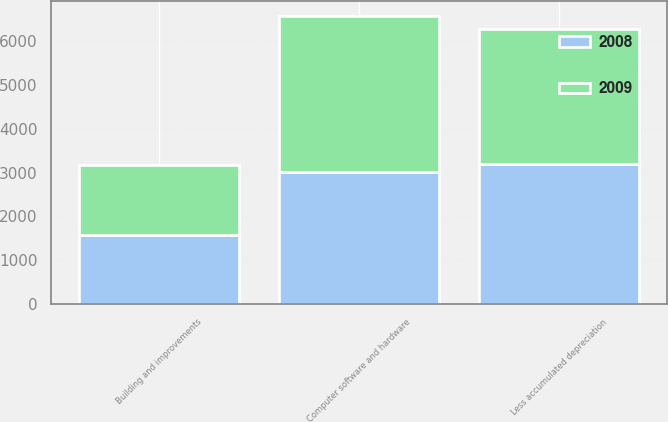Convert chart. <chart><loc_0><loc_0><loc_500><loc_500><stacked_bar_chart><ecel><fcel>Building and improvements<fcel>Computer software and hardware<fcel>Less accumulated depreciation<nl><fcel>2008<fcel>1581<fcel>3022<fcel>3198<nl><fcel>2009<fcel>1581<fcel>3553<fcel>3068<nl></chart> 